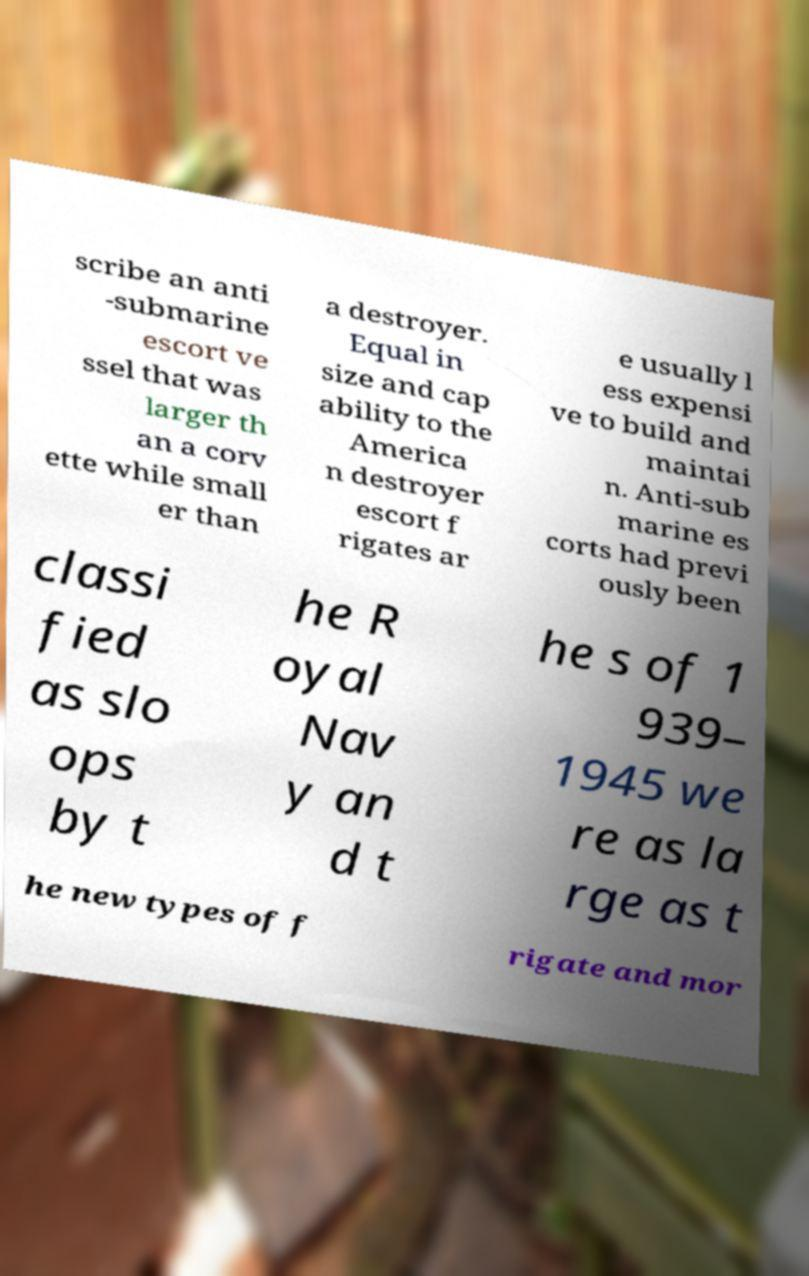Can you read and provide the text displayed in the image?This photo seems to have some interesting text. Can you extract and type it out for me? scribe an anti -submarine escort ve ssel that was larger th an a corv ette while small er than a destroyer. Equal in size and cap ability to the America n destroyer escort f rigates ar e usually l ess expensi ve to build and maintai n. Anti-sub marine es corts had previ ously been classi fied as slo ops by t he R oyal Nav y an d t he s of 1 939– 1945 we re as la rge as t he new types of f rigate and mor 